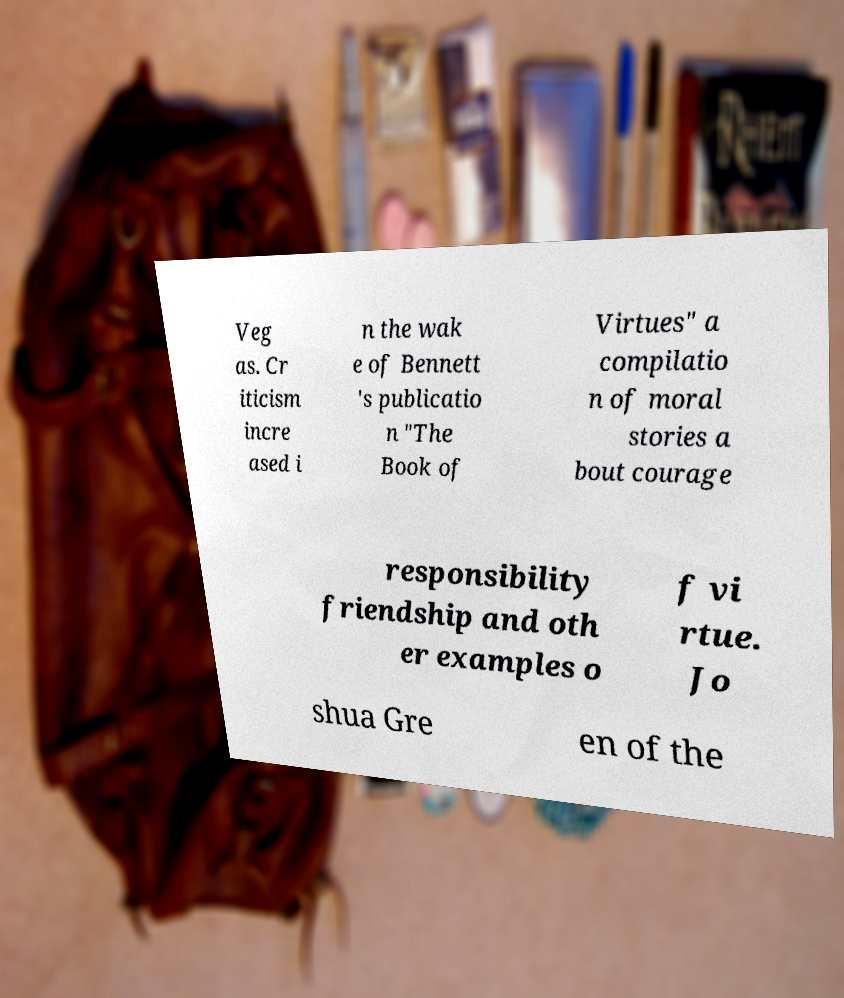There's text embedded in this image that I need extracted. Can you transcribe it verbatim? Veg as. Cr iticism incre ased i n the wak e of Bennett 's publicatio n "The Book of Virtues" a compilatio n of moral stories a bout courage responsibility friendship and oth er examples o f vi rtue. Jo shua Gre en of the 